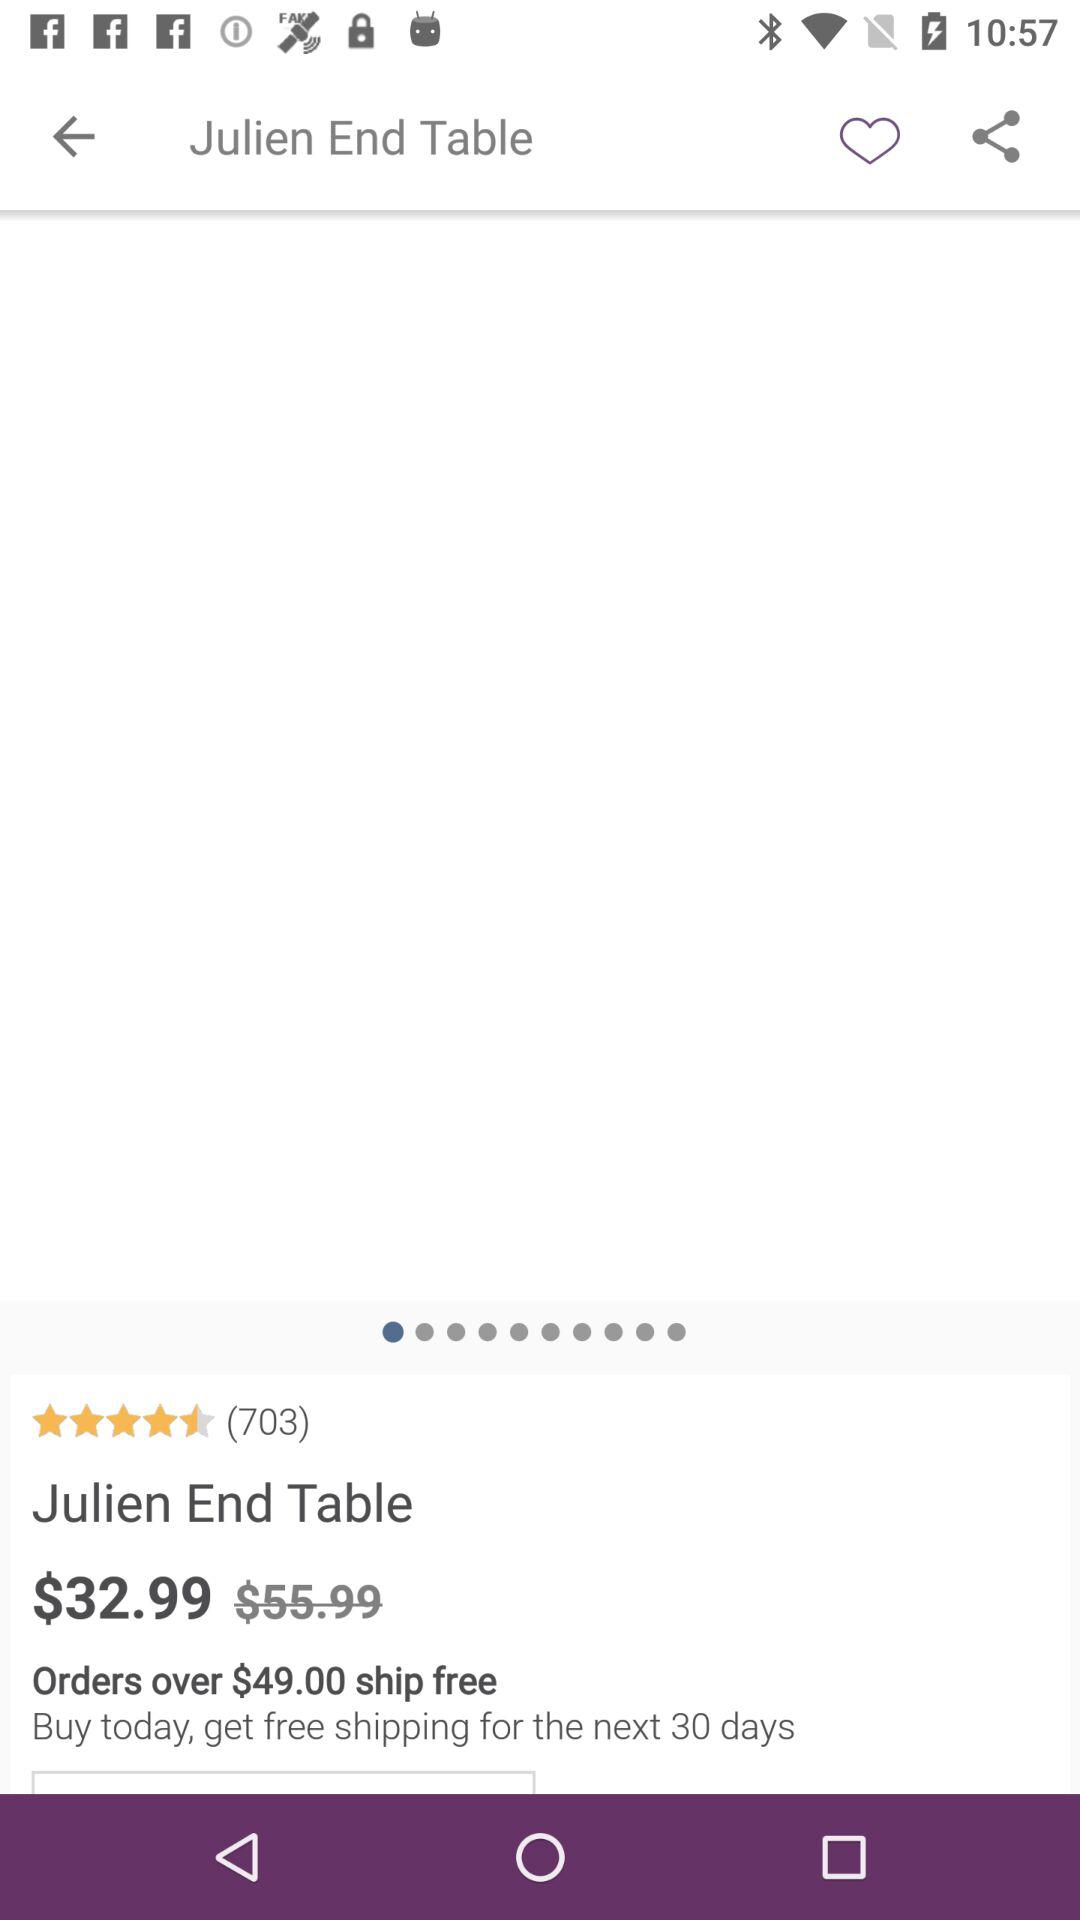What is the application name? The application name is Julien End Table. 